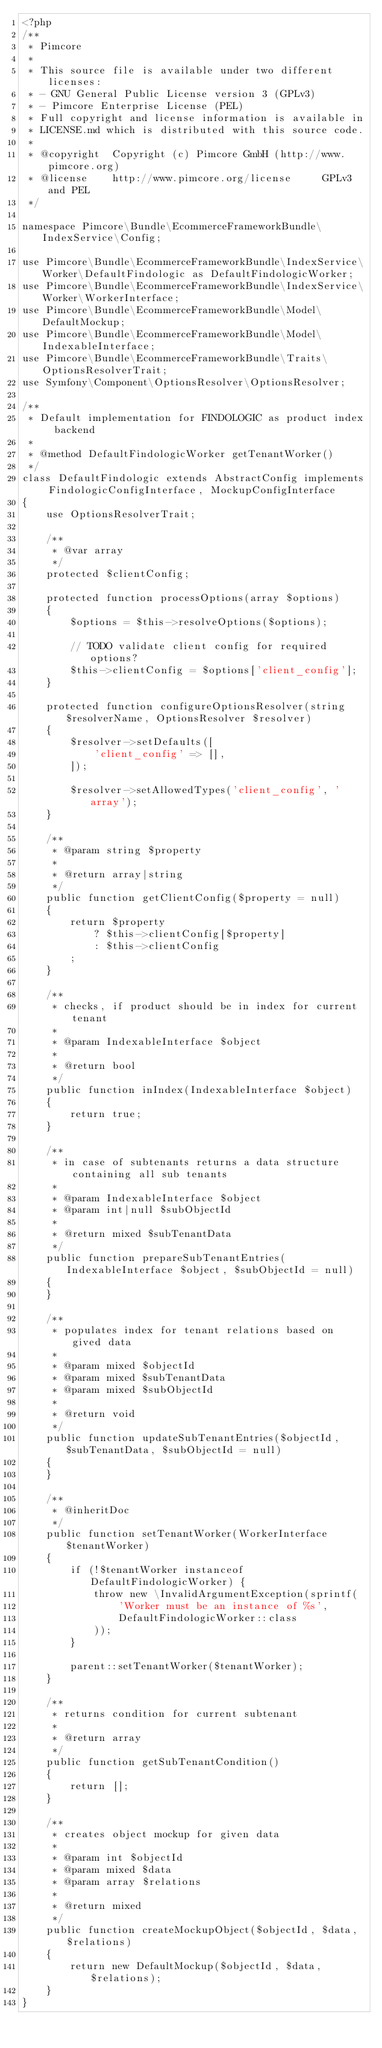<code> <loc_0><loc_0><loc_500><loc_500><_PHP_><?php
/**
 * Pimcore
 *
 * This source file is available under two different licenses:
 * - GNU General Public License version 3 (GPLv3)
 * - Pimcore Enterprise License (PEL)
 * Full copyright and license information is available in
 * LICENSE.md which is distributed with this source code.
 *
 * @copyright  Copyright (c) Pimcore GmbH (http://www.pimcore.org)
 * @license    http://www.pimcore.org/license     GPLv3 and PEL
 */

namespace Pimcore\Bundle\EcommerceFrameworkBundle\IndexService\Config;

use Pimcore\Bundle\EcommerceFrameworkBundle\IndexService\Worker\DefaultFindologic as DefaultFindologicWorker;
use Pimcore\Bundle\EcommerceFrameworkBundle\IndexService\Worker\WorkerInterface;
use Pimcore\Bundle\EcommerceFrameworkBundle\Model\DefaultMockup;
use Pimcore\Bundle\EcommerceFrameworkBundle\Model\IndexableInterface;
use Pimcore\Bundle\EcommerceFrameworkBundle\Traits\OptionsResolverTrait;
use Symfony\Component\OptionsResolver\OptionsResolver;

/**
 * Default implementation for FINDOLOGIC as product index backend
 *
 * @method DefaultFindologicWorker getTenantWorker()
 */
class DefaultFindologic extends AbstractConfig implements FindologicConfigInterface, MockupConfigInterface
{
    use OptionsResolverTrait;

    /**
     * @var array
     */
    protected $clientConfig;

    protected function processOptions(array $options)
    {
        $options = $this->resolveOptions($options);

        // TODO validate client config for required options?
        $this->clientConfig = $options['client_config'];
    }

    protected function configureOptionsResolver(string $resolverName, OptionsResolver $resolver)
    {
        $resolver->setDefaults([
            'client_config' => [],
        ]);

        $resolver->setAllowedTypes('client_config', 'array');
    }

    /**
     * @param string $property
     *
     * @return array|string
     */
    public function getClientConfig($property = null)
    {
        return $property
            ? $this->clientConfig[$property]
            : $this->clientConfig
        ;
    }

    /**
     * checks, if product should be in index for current tenant
     *
     * @param IndexableInterface $object
     *
     * @return bool
     */
    public function inIndex(IndexableInterface $object)
    {
        return true;
    }

    /**
     * in case of subtenants returns a data structure containing all sub tenants
     *
     * @param IndexableInterface $object
     * @param int|null $subObjectId
     *
     * @return mixed $subTenantData
     */
    public function prepareSubTenantEntries(IndexableInterface $object, $subObjectId = null)
    {
    }

    /**
     * populates index for tenant relations based on gived data
     *
     * @param mixed $objectId
     * @param mixed $subTenantData
     * @param mixed $subObjectId
     *
     * @return void
     */
    public function updateSubTenantEntries($objectId, $subTenantData, $subObjectId = null)
    {
    }

    /**
     * @inheritDoc
     */
    public function setTenantWorker(WorkerInterface $tenantWorker)
    {
        if (!$tenantWorker instanceof DefaultFindologicWorker) {
            throw new \InvalidArgumentException(sprintf(
                'Worker must be an instance of %s',
                DefaultFindologicWorker::class
            ));
        }

        parent::setTenantWorker($tenantWorker);
    }

    /**
     * returns condition for current subtenant
     *
     * @return array
     */
    public function getSubTenantCondition()
    {
        return [];
    }

    /**
     * creates object mockup for given data
     *
     * @param int $objectId
     * @param mixed $data
     * @param array $relations
     *
     * @return mixed
     */
    public function createMockupObject($objectId, $data, $relations)
    {
        return new DefaultMockup($objectId, $data, $relations);
    }
}
</code> 